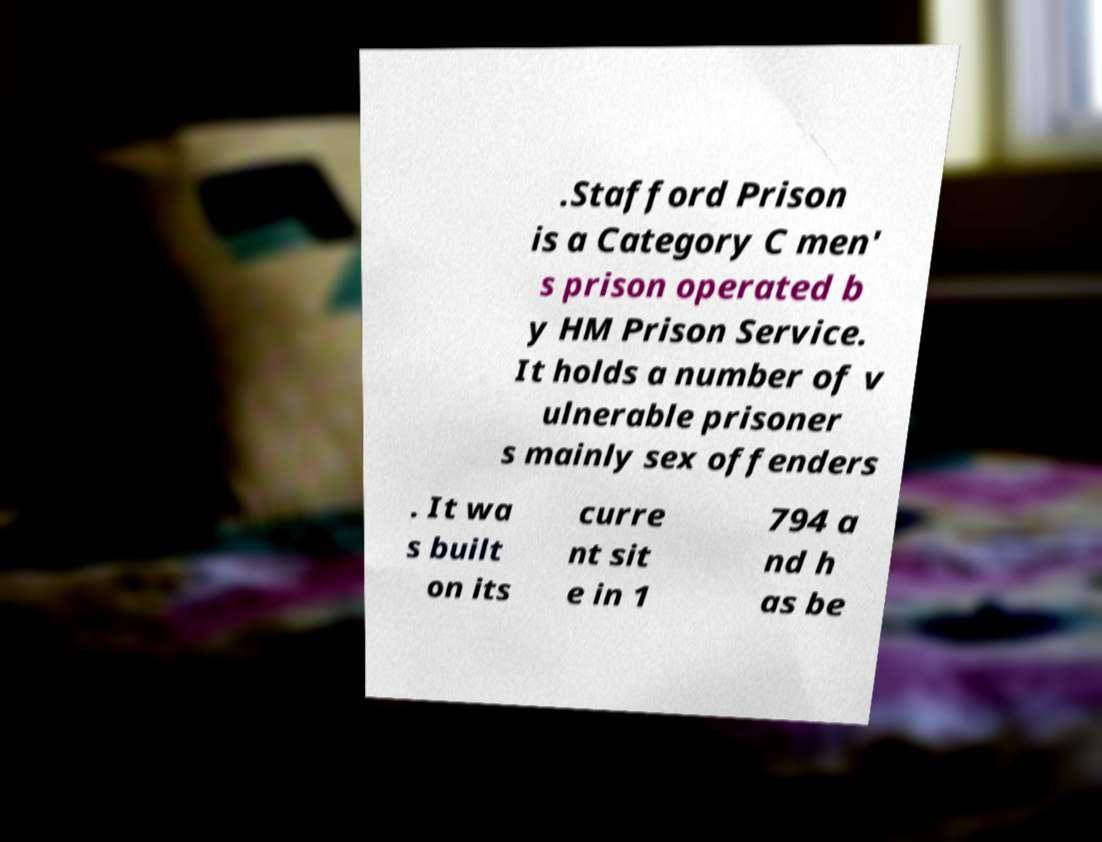For documentation purposes, I need the text within this image transcribed. Could you provide that? .Stafford Prison is a Category C men' s prison operated b y HM Prison Service. It holds a number of v ulnerable prisoner s mainly sex offenders . It wa s built on its curre nt sit e in 1 794 a nd h as be 